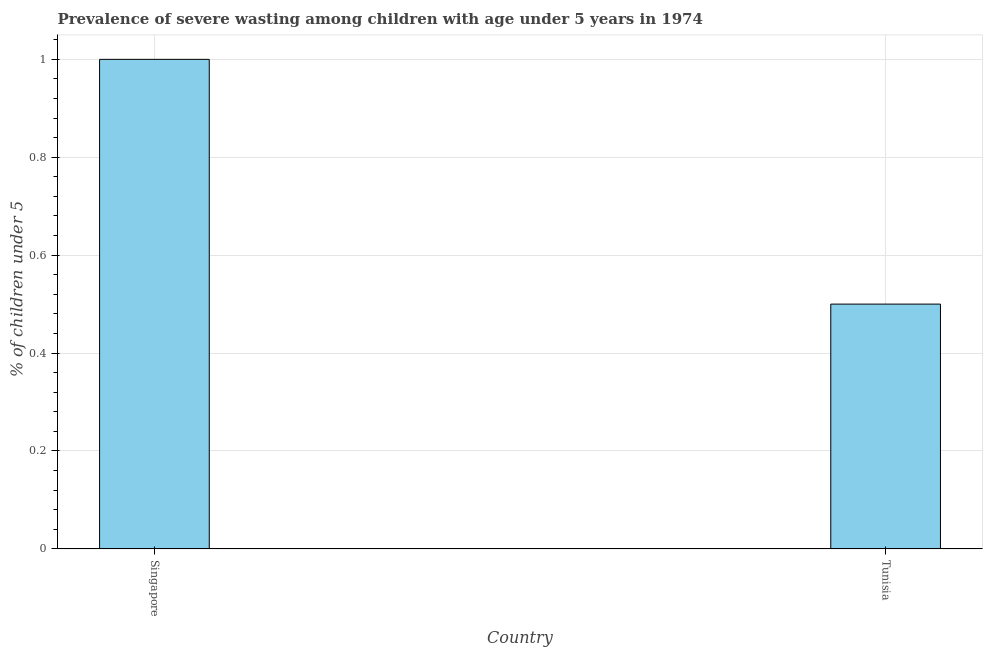Does the graph contain grids?
Ensure brevity in your answer.  Yes. What is the title of the graph?
Give a very brief answer. Prevalence of severe wasting among children with age under 5 years in 1974. What is the label or title of the X-axis?
Give a very brief answer. Country. What is the label or title of the Y-axis?
Provide a succinct answer.  % of children under 5. Across all countries, what is the maximum prevalence of severe wasting?
Keep it short and to the point. 1. Across all countries, what is the minimum prevalence of severe wasting?
Your answer should be very brief. 0.5. In which country was the prevalence of severe wasting maximum?
Your response must be concise. Singapore. In which country was the prevalence of severe wasting minimum?
Provide a succinct answer. Tunisia. What is the sum of the prevalence of severe wasting?
Offer a very short reply. 1.5. What is the average prevalence of severe wasting per country?
Offer a very short reply. 0.75. What is the median prevalence of severe wasting?
Your response must be concise. 0.75. In how many countries, is the prevalence of severe wasting greater than 0.8 %?
Your answer should be very brief. 1. What is the ratio of the prevalence of severe wasting in Singapore to that in Tunisia?
Offer a terse response. 2. In how many countries, is the prevalence of severe wasting greater than the average prevalence of severe wasting taken over all countries?
Your response must be concise. 1. How many countries are there in the graph?
Provide a short and direct response. 2. What is the difference between two consecutive major ticks on the Y-axis?
Keep it short and to the point. 0.2. 